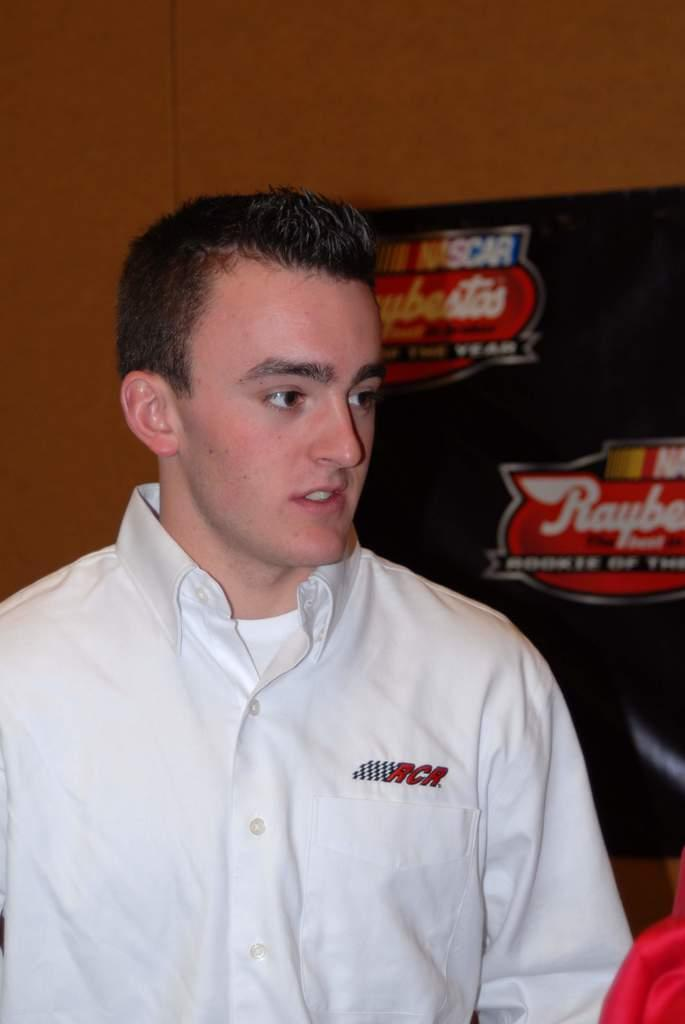What is present in the image? There is a person in the image. Can you describe the person's attire? The person is wearing a white dress. What can be seen in the background of the image? There is a wall in the background of the image. What is attached to the wall? A black color sheet is attached to the wall. Is the person holding a gun in the image? No, there is no gun present in the image. 